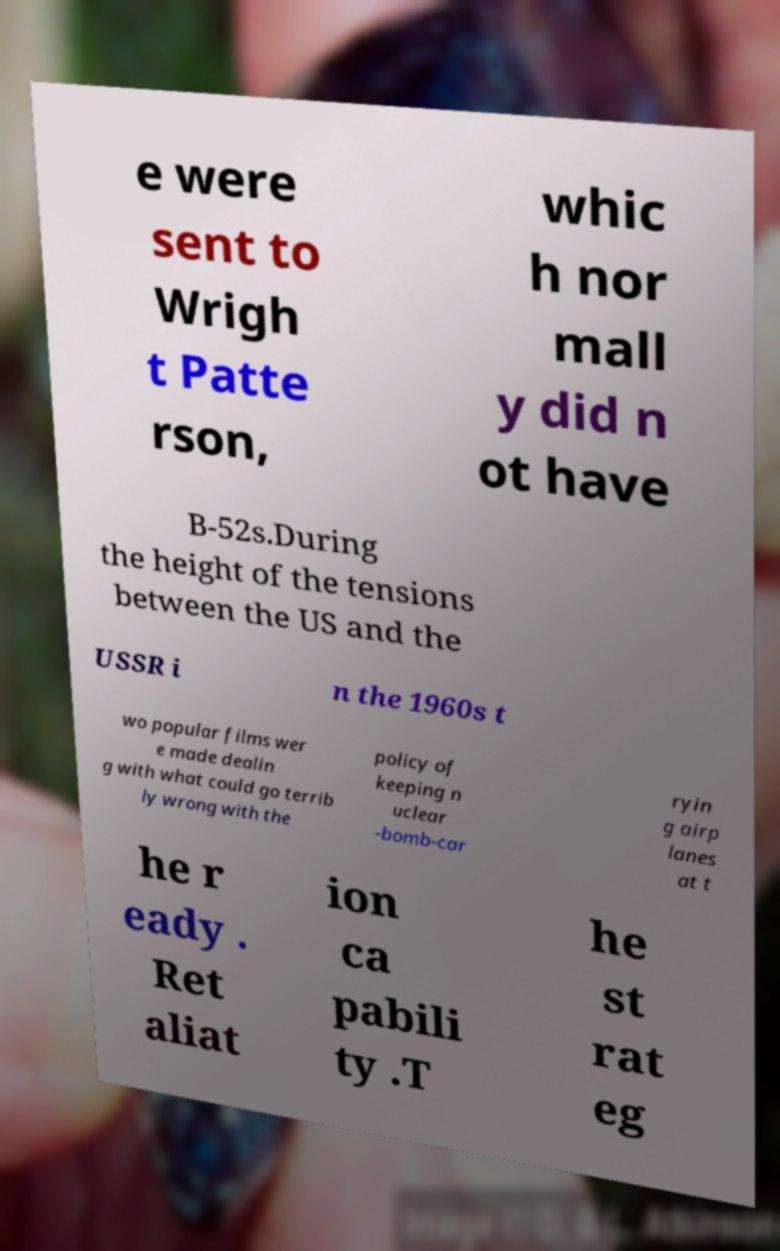Please identify and transcribe the text found in this image. e were sent to Wrigh t Patte rson, whic h nor mall y did n ot have B-52s.During the height of the tensions between the US and the USSR i n the 1960s t wo popular films wer e made dealin g with what could go terrib ly wrong with the policy of keeping n uclear -bomb-car ryin g airp lanes at t he r eady . Ret aliat ion ca pabili ty .T he st rat eg 